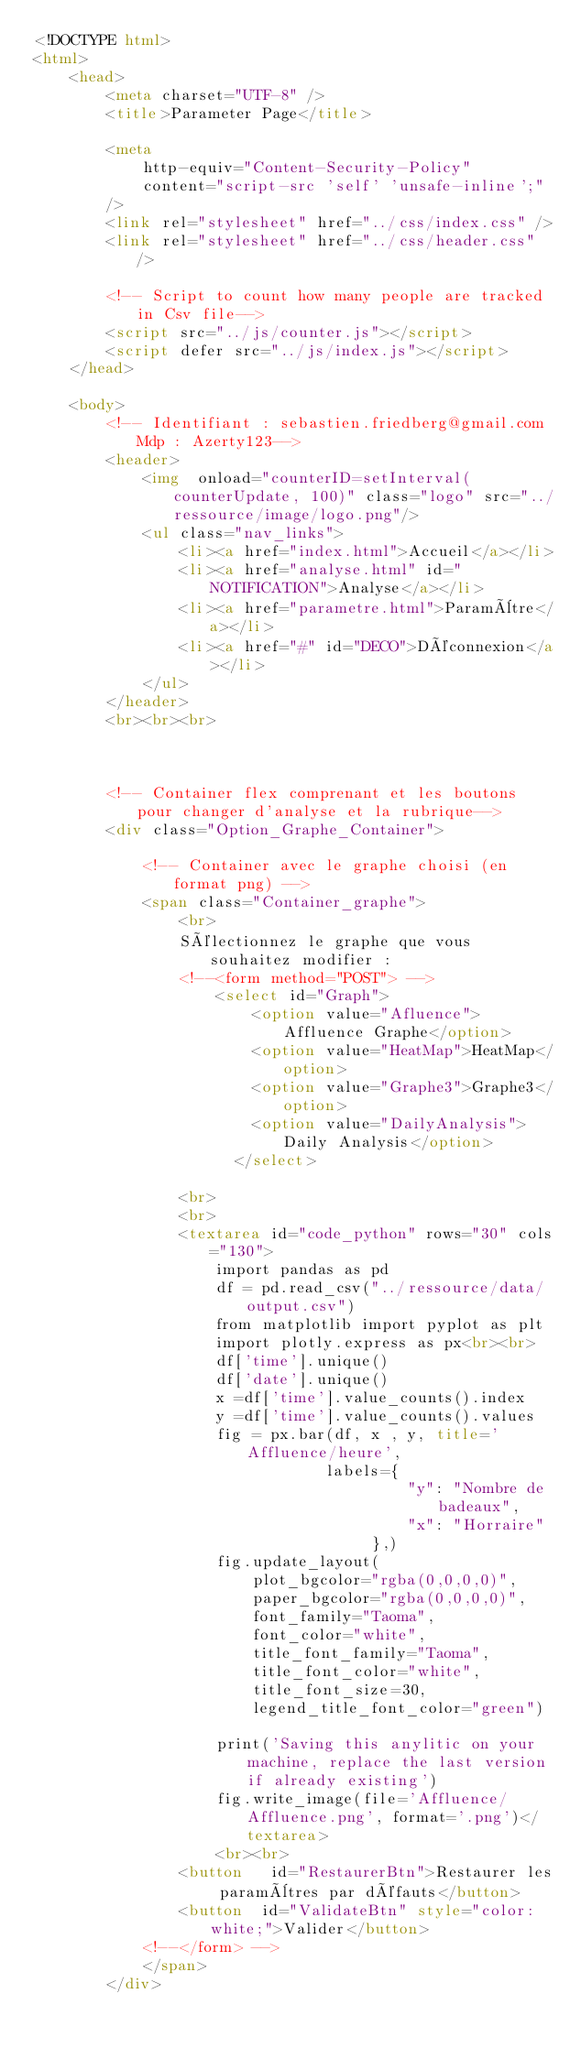Convert code to text. <code><loc_0><loc_0><loc_500><loc_500><_HTML_><!DOCTYPE html>
<html>
	<head>
		<meta charset="UTF-8" />
		<title>Parameter Page</title>

		<meta
			http-equiv="Content-Security-Policy"
			content="script-src 'self' 'unsafe-inline';"
		/>
		<link rel="stylesheet" href="../css/index.css" />
		<link rel="stylesheet" href="../css/header.css" />

        <!-- Script to count how many people are tracked in Csv file-->
		<script src="../js/counter.js"></script>
		<script defer src="../js/index.js"></script>
	</head>

	<body>
		<!-- Identifiant : sebastien.friedberg@gmail.com Mdp : Azerty123-->
		<header>
			<img  onload="counterID=setInterval(counterUpdate, 100)" class="logo" src="../ressource/image/logo.png"/>
			<ul class="nav_links">
				<li><a href="index.html">Accueil</a></li>
				<li><a href="analyse.html" id="NOTIFICATION">Analyse</a></li>
				<li><a href="parametre.html">Paramètre</a></li>
				<li><a href="#" id="DECO">Déconnexion</a></li>
			</ul>
		</header>
		<br><br><br>


		
		<!-- Container flex comprenant et les boutons pour changer d'analyse et la rubrique-->
		<div class="Option_Graphe_Container">

			<!-- Container avec le graphe choisi (en format png) -->
			<span class="Container_graphe"> 
                <br>
                Sélectionnez le graphe que vous souhaitez modifier : 
                <!--<form method="POST"> -->
                    <select id="Graph">
                        <option value="Afluence">Affluence Graphe</option>
                        <option value="HeatMap">HeatMap</option>
                        <option value="Graphe3">Graphe3</option>
                        <option value="DailyAnalysis">Daily Analysis</option>
                      </select>
                
                <br>
                <br>
                <textarea id="code_python" rows="30" cols="130">
                    import pandas as pd
                    df = pd.read_csv("../ressource/data/output.csv")
                    from matplotlib import pyplot as plt
                    import plotly.express as px<br><br>
                    df['time'].unique()
                    df['date'].unique()
                    x =df['time'].value_counts().index
                    y =df['time'].value_counts().values
                    fig = px.bar(df, x , y, title='Affluence/heure',
                                labels={
                                         "y": "Nombre de badeaux",
                                         "x": "Horraire"
                                     },)
                    fig.update_layout(
                        plot_bgcolor="rgba(0,0,0,0)",
                        paper_bgcolor="rgba(0,0,0,0)",
                        font_family="Taoma",
                        font_color="white",
                        title_font_family="Taoma",
                        title_font_color="white",
                        title_font_size=30,
                        legend_title_font_color="green")
                    
                    print('Saving this anylitic on your machine, replace the last version if already existing')
                    fig.write_image(file='Affluence/Affluence.png', format='.png')</textarea>
                    <br><br>
                <button   id="RestaurerBtn">Restaurer les paramètres par défauts</button>
                <button  id="ValidateBtn" style="color:white;">Valider</button>
            <!--</form> -->
            </span>
		</div>
        </code> 